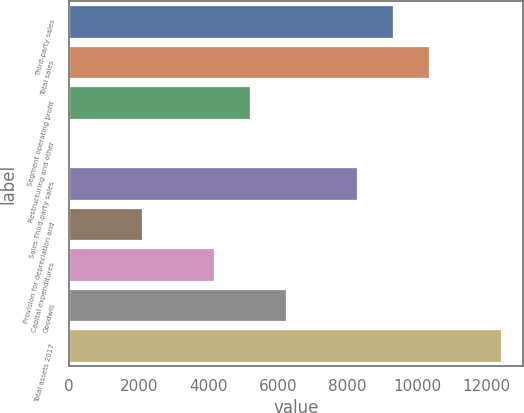<chart> <loc_0><loc_0><loc_500><loc_500><bar_chart><fcel>Third-party sales<fcel>Total sales<fcel>Segment operating profit<fcel>Restructuring and other<fcel>Sales Third-party sales<fcel>Provision for depreciation and<fcel>Capital expenditures<fcel>Goodwill<fcel>Total assets 2017<nl><fcel>9314.4<fcel>10346<fcel>5188<fcel>30<fcel>8282.8<fcel>2093.2<fcel>4156.4<fcel>6219.6<fcel>12409.2<nl></chart> 